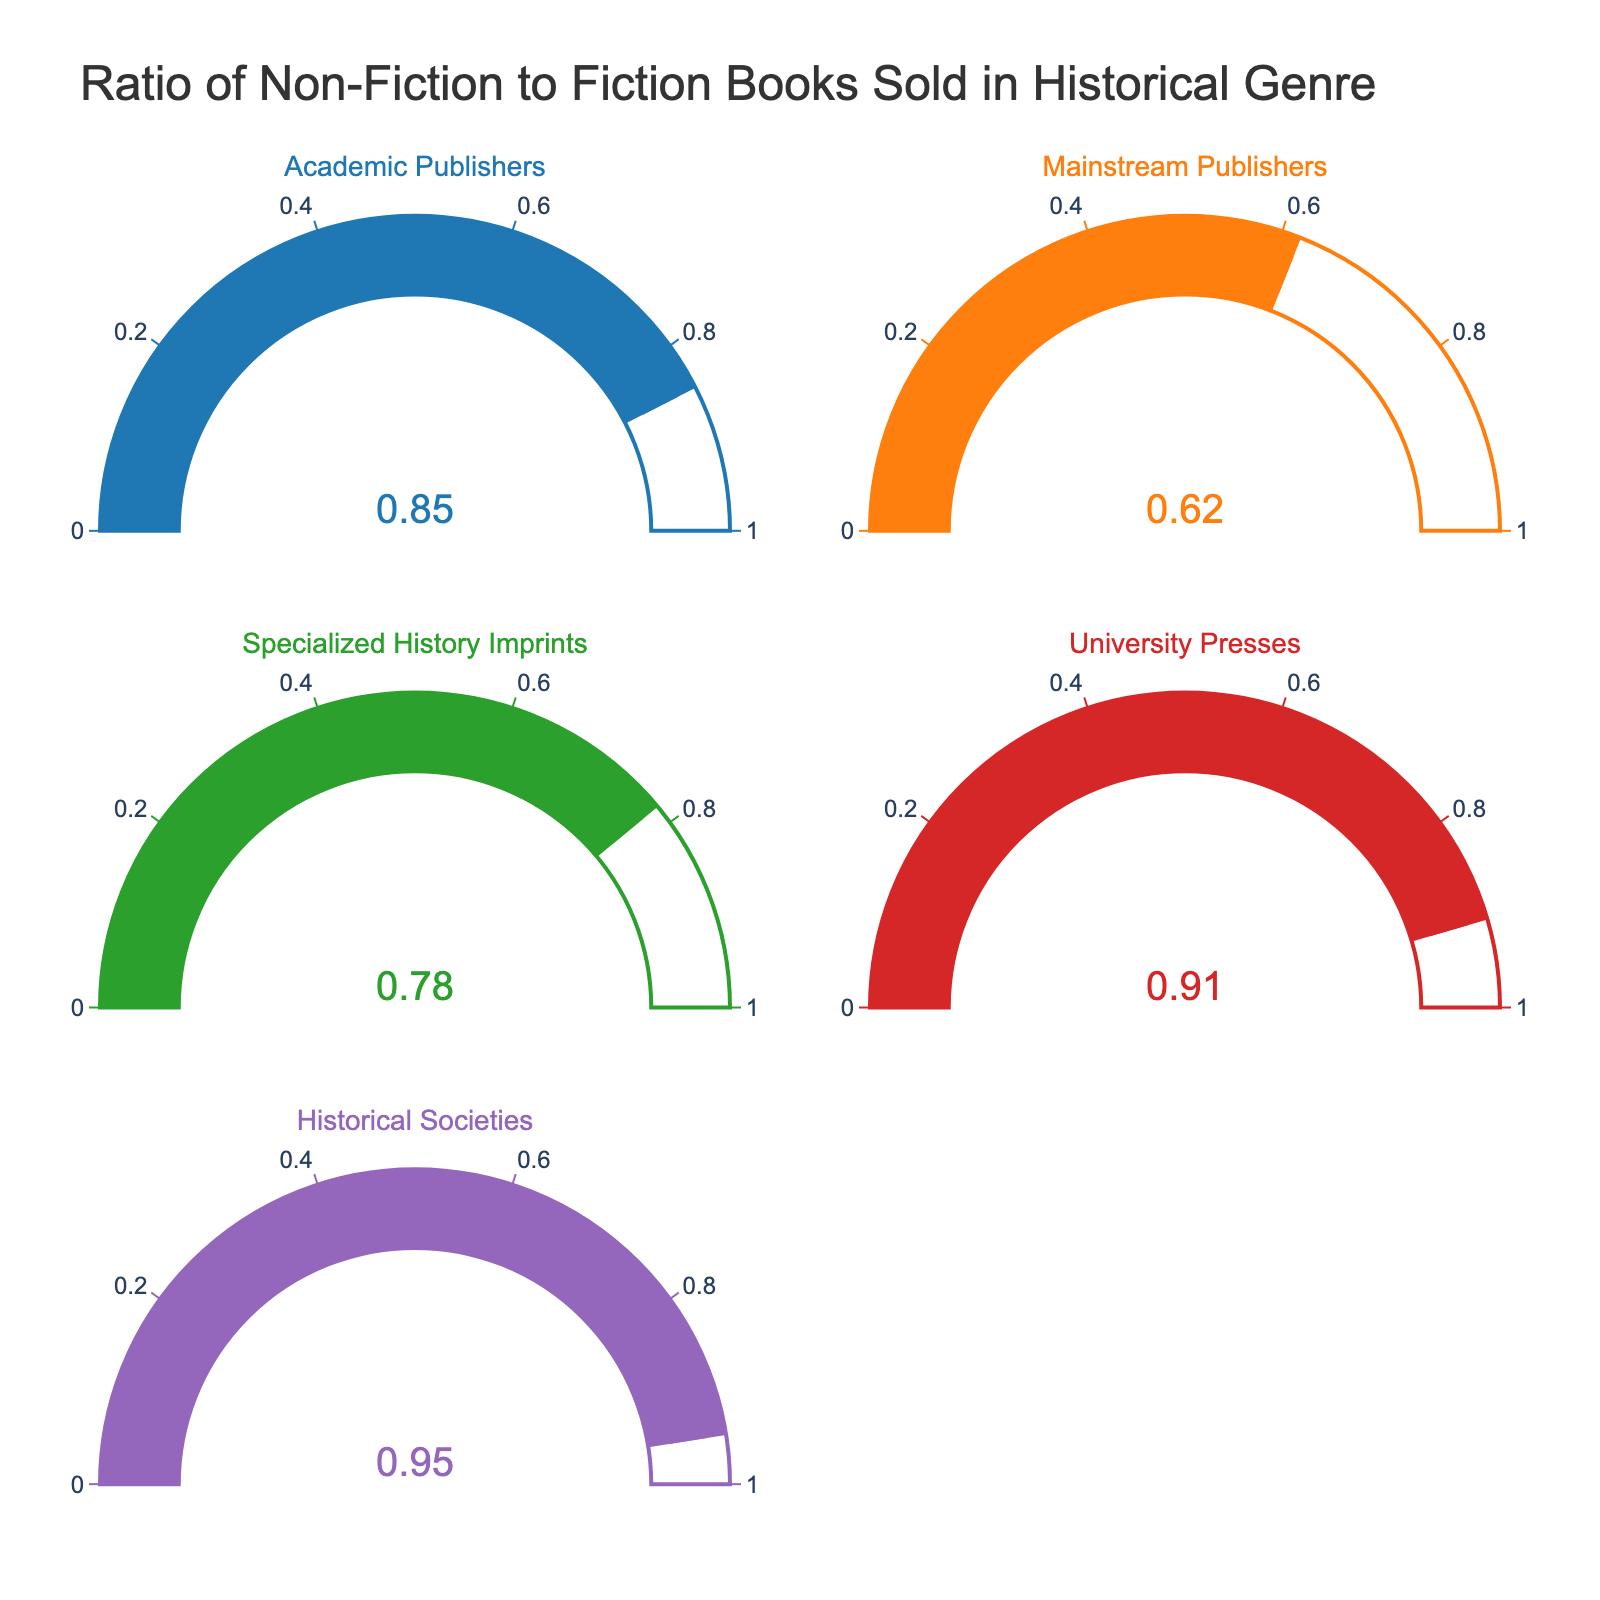What is the title of the figure? The title is usually at the top of the figure, representing an overview of what the data or visual represents.
Answer: Ratio of Non-Fiction to Fiction Books Sold in Historical Genre Which category has the highest ratio of non-fiction books sold? Look for the gauge with the highest number. In the figure, it is essential to identify the gauge showing the largest value.
Answer: Historical Societies What is the ratio of non-fiction books sold by Mainstream Publishers? Check the value displayed on the gauge titled "Mainstream Publishers".
Answer: 0.62 What is the difference in the non-fiction ratio between University Presses and Specialized History Imprints? Find the values for both University Presses (0.91) and Specialized History Imprints (0.78), then calculate the difference: 0.91 - 0.78.
Answer: 0.13 How does the non-fiction ratio of Academic Publishers compare to that of Specialized History Imprints? Compare the values of the two categories. Academic Publishers have a value of 0.85, while Specialized History Imprints have 0.78.
Answer: Academic Publishers have a higher ratio What is the median ratio of non-fiction books across all categories? List all ratios: 0.85, 0.62, 0.78, 0.91, and 0.95. Arrange them in ascending order: 0.62, 0.78, 0.85, 0.91, 0.95. The median is the middle number.
Answer: 0.85 Which category has the lowest non-fiction ratio, and what is that value? Identify the lowest number among the gauges.
Answer: Mainstream Publishers, 0.62 What is the average non-fiction ratio for all categories? Sum up all values and divide by the number of categories: (0.85 + 0.62 + 0.78 + 0.91 + 0.95) / 5.
Answer: 0.822 How many categories have a non-fiction ratio greater than 0.8? Count the gauges that display a value higher than 0.8. The relevant values are 0.85, 0.91, and 0.95.
Answer: 3 If we were to rank the categories by their non-fiction ratio, which would be the third-highest? Arrange the values in descending order: 0.95 (Historical Societies), 0.91 (University Presses), 0.85 (Academic Publishers), 0.78 (Specialized History Imprints), 0.62 (Mainstream Publishers). The third-highest is 0.85 for Academic Publishers.
Answer: Academic Publishers 